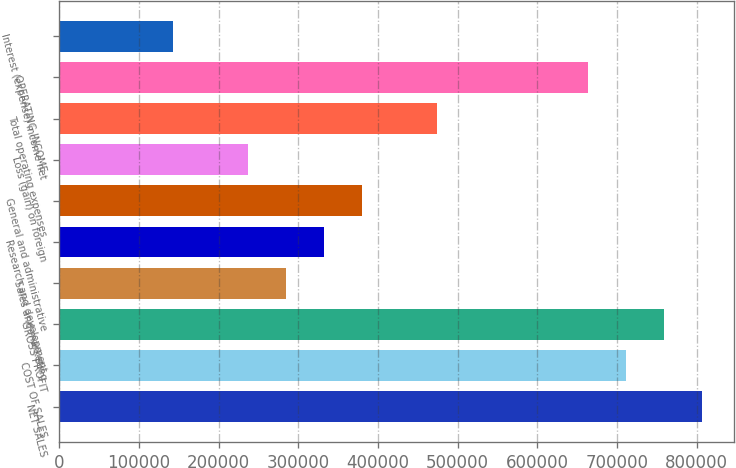Convert chart. <chart><loc_0><loc_0><loc_500><loc_500><bar_chart><fcel>NET SALES<fcel>COST OF SALES<fcel>GROSS PROFIT<fcel>Sales and marketing<fcel>Research and development<fcel>General and administrative<fcel>Loss (gain) on foreign<fcel>Total operating expenses<fcel>OPERATING INCOME<fcel>Interest (expense) income net<nl><fcel>806618<fcel>711722<fcel>759170<fcel>284690<fcel>332138<fcel>379586<fcel>237242<fcel>474482<fcel>664274<fcel>142346<nl></chart> 